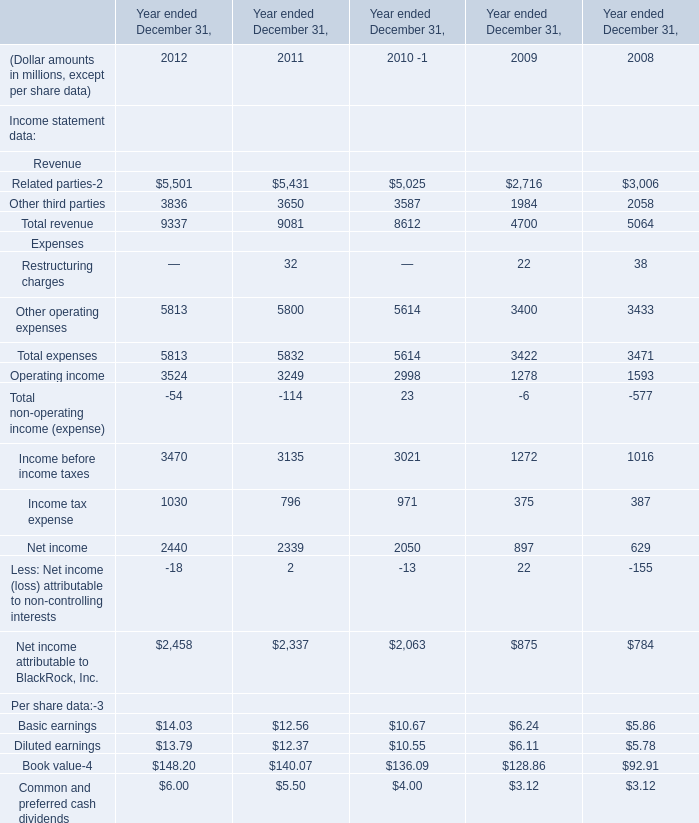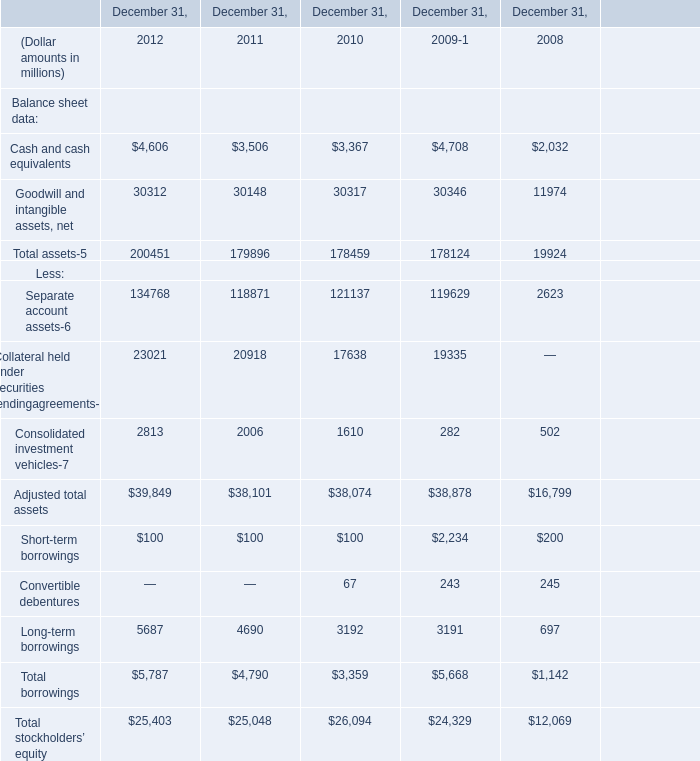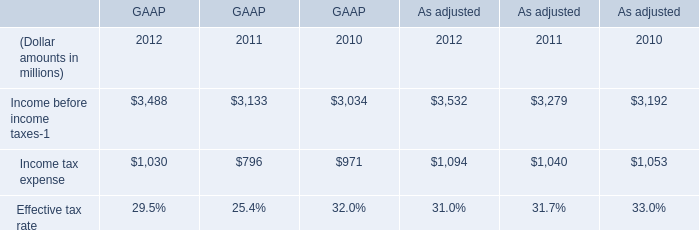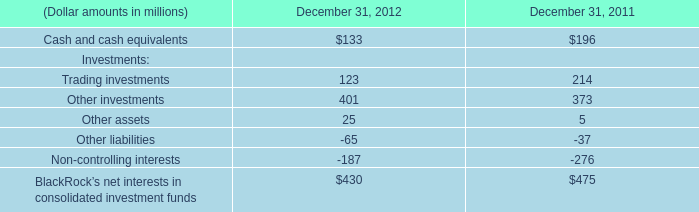What will Total expenses reach in 2013 if it continues to grow at its current rate? (in million) 
Computations: ((1 + ((5813 - 5832) / 5832)) * 5813)
Answer: 5794.0619. 